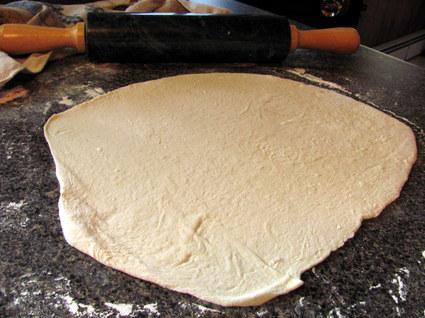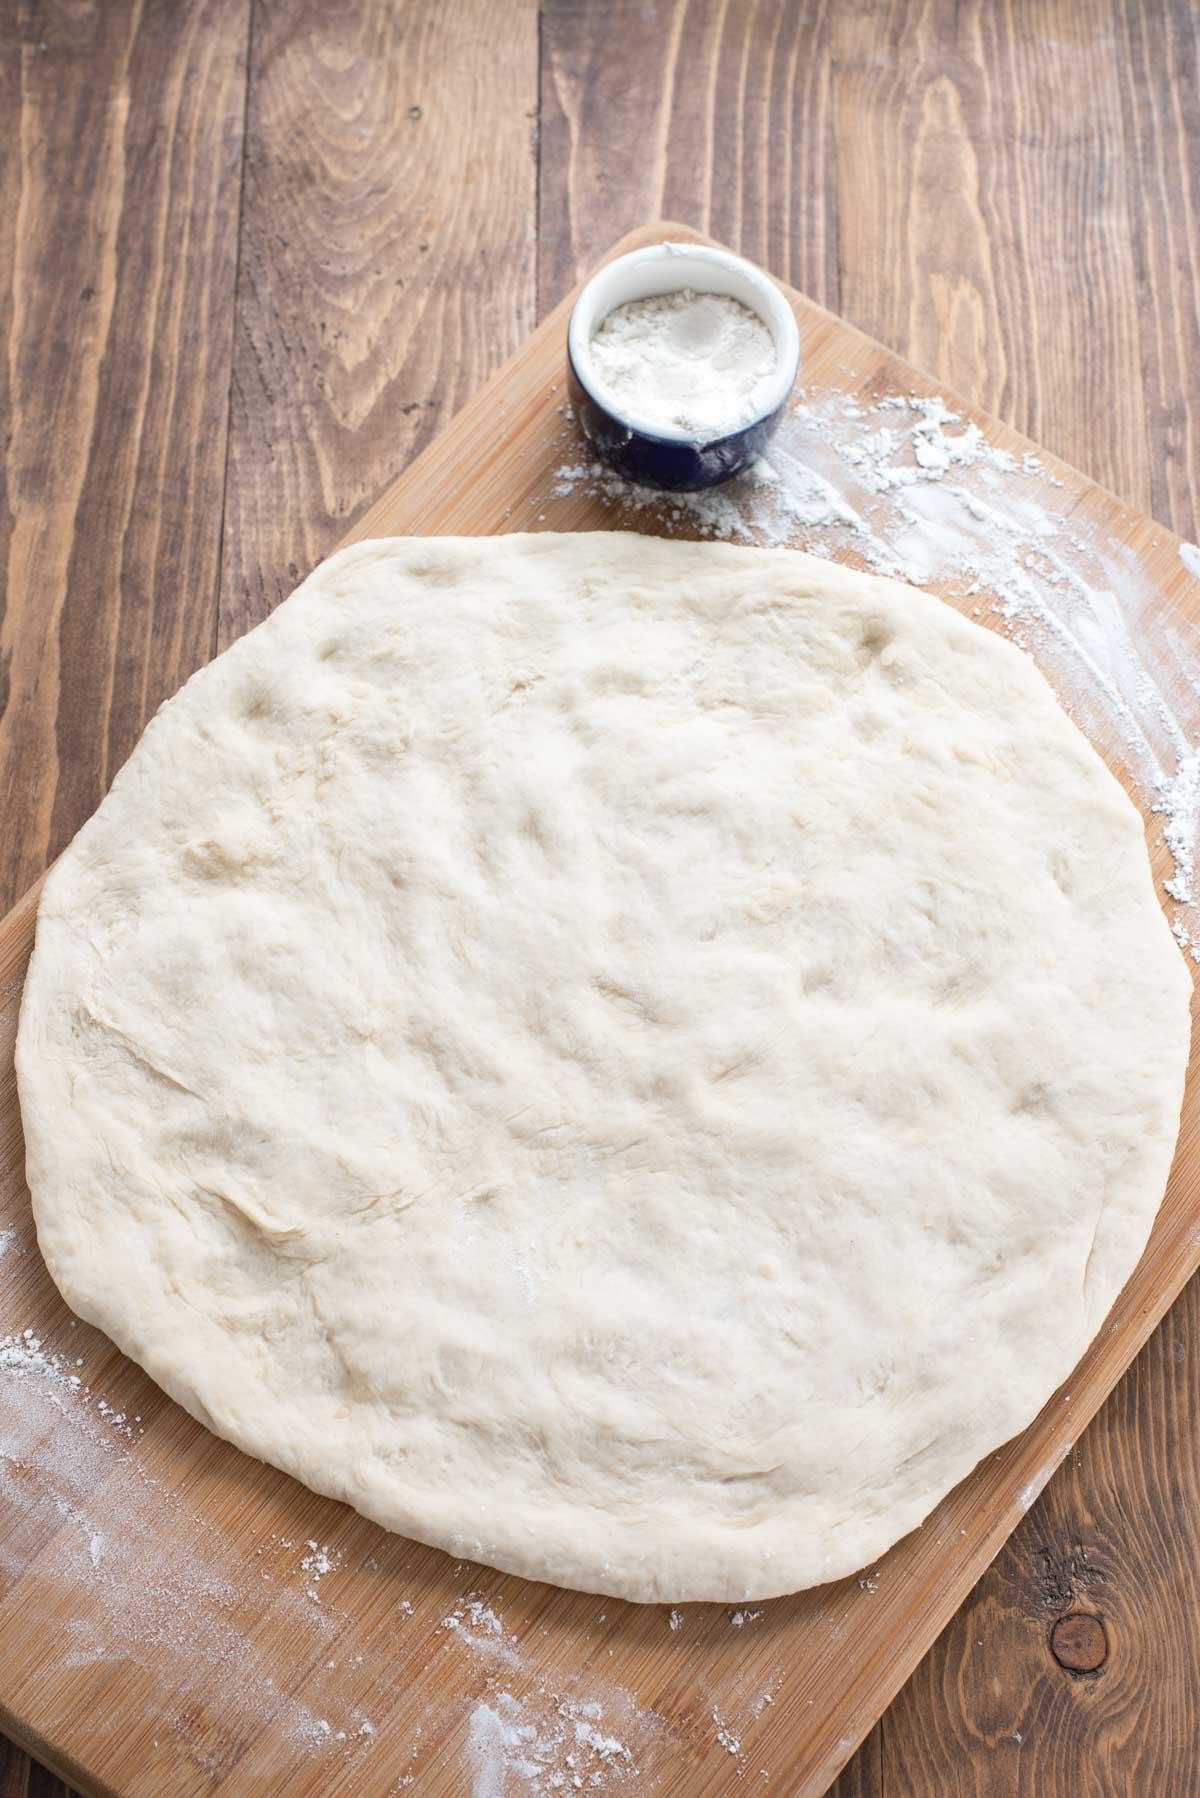The first image is the image on the left, the second image is the image on the right. Examine the images to the left and right. Is the description "At least one image has a large ball of dough in a bowl-like container, and not directly on a flat surface." accurate? Answer yes or no. No. The first image is the image on the left, the second image is the image on the right. Considering the images on both sides, is "Each image contains one rounded mound of bread dough, and at least one of the depicted dough mounds is in a metal container." valid? Answer yes or no. No. 